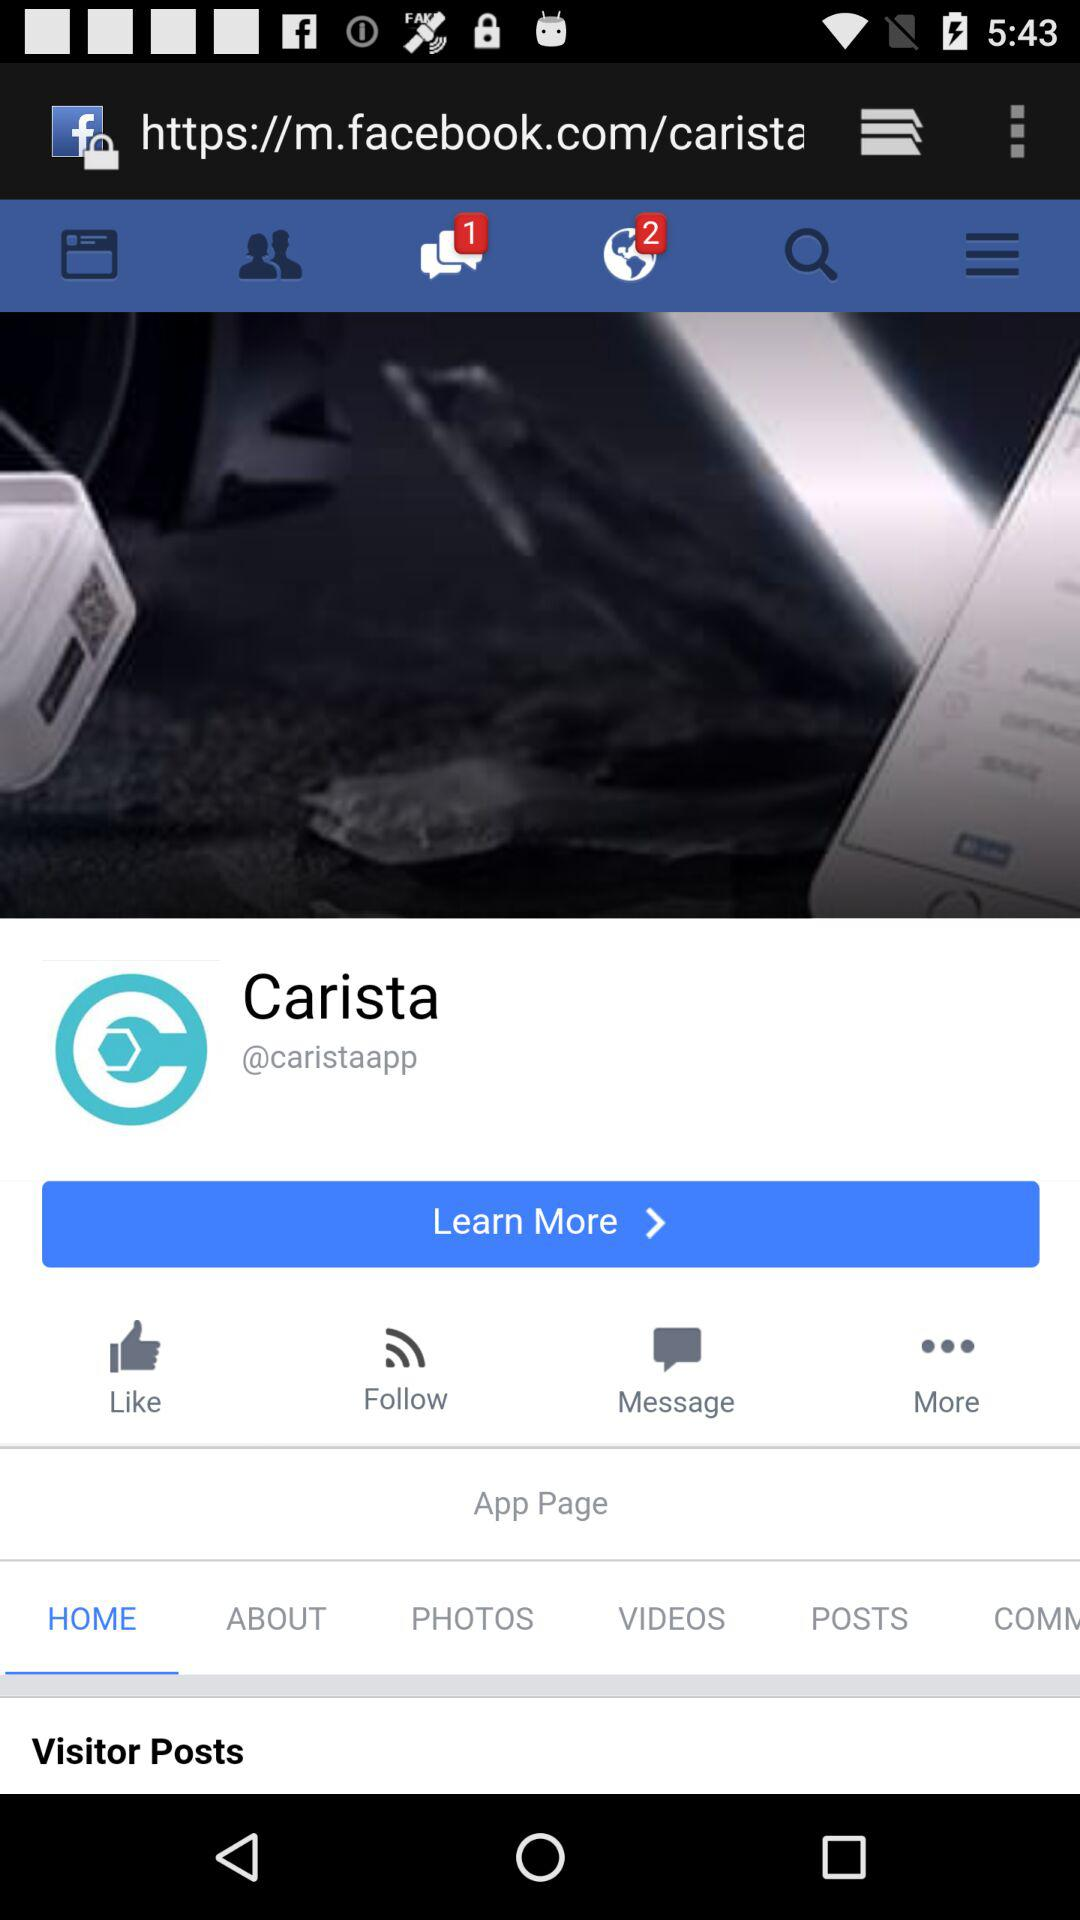How many unread notifications are there? There are 2 unread notifications. 